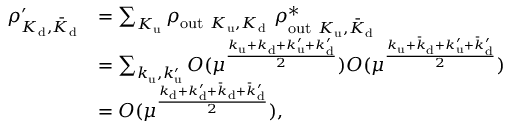Convert formula to latex. <formula><loc_0><loc_0><loc_500><loc_500>\begin{array} { r l } { \rho _ { K _ { d } , \bar { K } _ { d } } ^ { \prime } } & { = \sum _ { K _ { u } } \rho _ { o u t K _ { u } , K _ { d } } \rho _ { o u t K _ { u } , \bar { K } _ { d } } ^ { * } } \\ & { = \sum _ { k _ { u } , k _ { u } ^ { \prime } } O ( \mu ^ { \frac { k _ { u } + k _ { d } + k _ { u } ^ { \prime } + k _ { d } ^ { \prime } } { 2 } } ) O ( \mu ^ { \frac { k _ { u } + \bar { k } _ { d } + k _ { u } ^ { \prime } + \bar { k } _ { d } ^ { \prime } } { 2 } } ) } \\ & { = O ( \mu ^ { \frac { k _ { d } + k _ { d } ^ { \prime } + \bar { k } _ { d } + \bar { k } _ { d } ^ { \prime } } { 2 } } ) , } \end{array}</formula> 